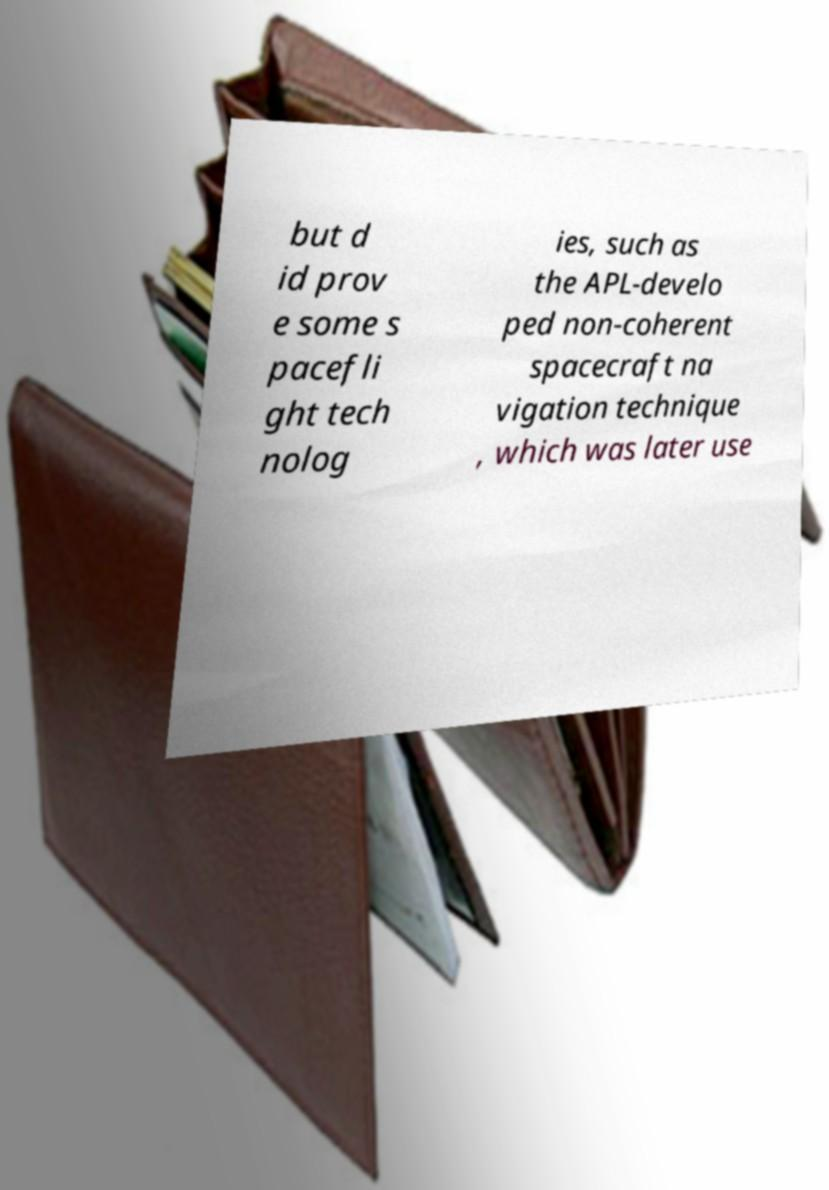Could you extract and type out the text from this image? but d id prov e some s pacefli ght tech nolog ies, such as the APL-develo ped non-coherent spacecraft na vigation technique , which was later use 